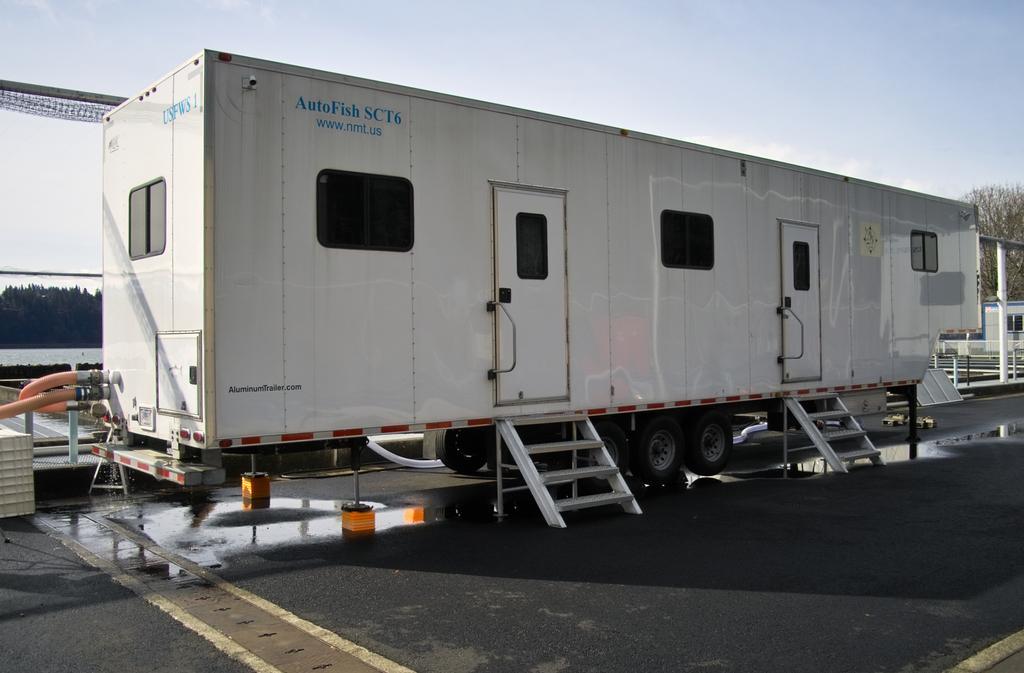Can you describe this image briefly? Here we can see a vehicle container. To this vehicle container there are steps, doors, windows and wheels. Background we can see the sky, trees, pipes and rods. Far there is a shed.  